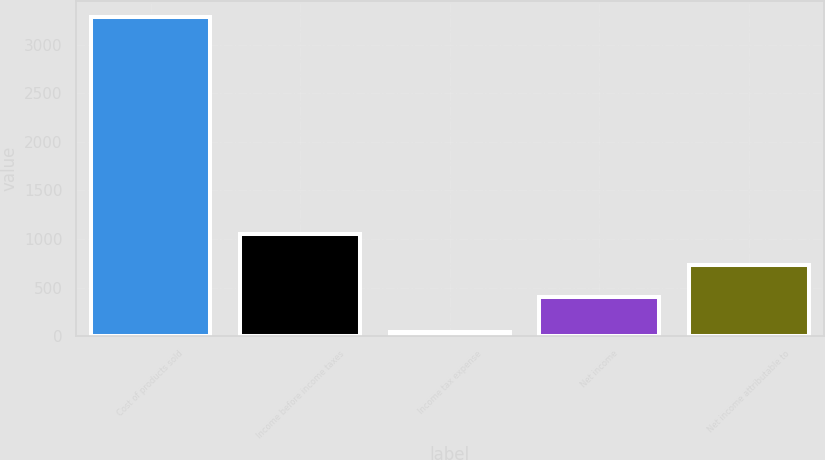Convert chart to OTSL. <chart><loc_0><loc_0><loc_500><loc_500><bar_chart><fcel>Cost of products sold<fcel>Income before income taxes<fcel>Income tax expense<fcel>Net income<fcel>Net income attributable to<nl><fcel>3291<fcel>1053.4<fcel>39<fcel>403<fcel>728.2<nl></chart> 